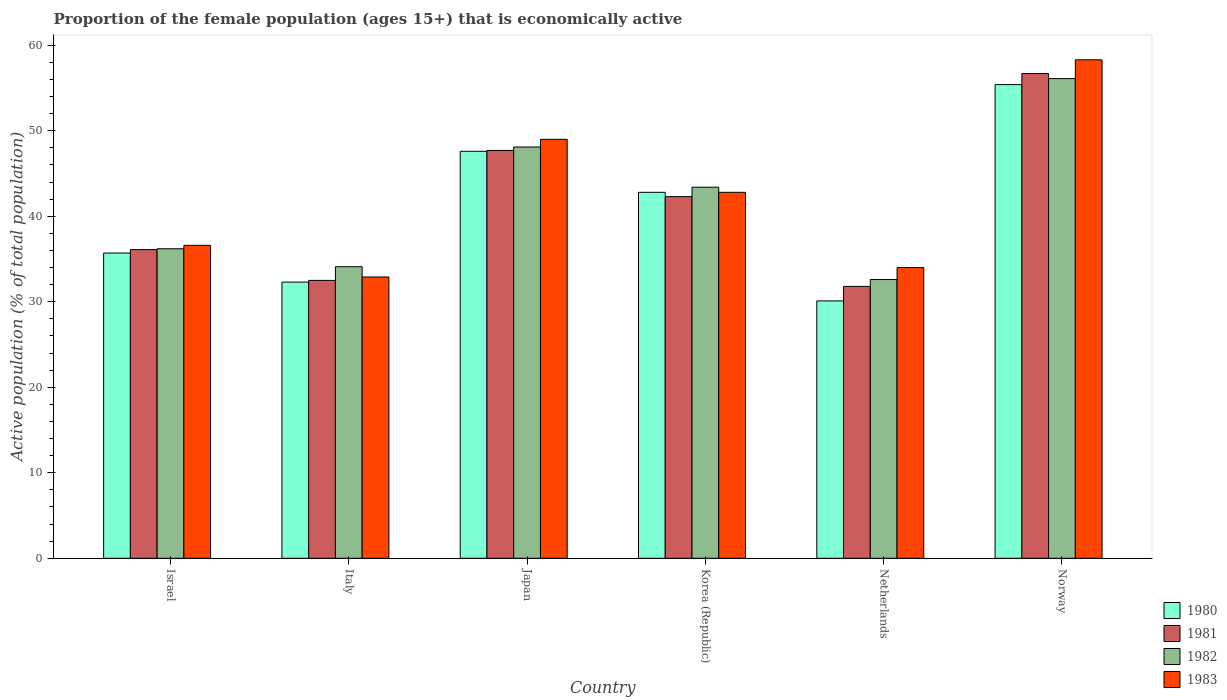How many groups of bars are there?
Offer a very short reply. 6. Are the number of bars per tick equal to the number of legend labels?
Ensure brevity in your answer.  Yes. How many bars are there on the 1st tick from the left?
Give a very brief answer. 4. What is the label of the 1st group of bars from the left?
Provide a short and direct response. Israel. What is the proportion of the female population that is economically active in 1982 in Korea (Republic)?
Your answer should be compact. 43.4. Across all countries, what is the maximum proportion of the female population that is economically active in 1981?
Your answer should be very brief. 56.7. Across all countries, what is the minimum proportion of the female population that is economically active in 1983?
Provide a succinct answer. 32.9. In which country was the proportion of the female population that is economically active in 1983 maximum?
Provide a succinct answer. Norway. In which country was the proportion of the female population that is economically active in 1983 minimum?
Provide a short and direct response. Italy. What is the total proportion of the female population that is economically active in 1980 in the graph?
Keep it short and to the point. 243.9. What is the difference between the proportion of the female population that is economically active in 1982 in Netherlands and that in Norway?
Ensure brevity in your answer.  -23.5. What is the difference between the proportion of the female population that is economically active in 1983 in Norway and the proportion of the female population that is economically active in 1982 in Italy?
Offer a very short reply. 24.2. What is the average proportion of the female population that is economically active in 1983 per country?
Offer a terse response. 42.27. What is the difference between the proportion of the female population that is economically active of/in 1980 and proportion of the female population that is economically active of/in 1982 in Netherlands?
Provide a short and direct response. -2.5. What is the ratio of the proportion of the female population that is economically active in 1981 in Korea (Republic) to that in Netherlands?
Your response must be concise. 1.33. Is the proportion of the female population that is economically active in 1981 in Italy less than that in Korea (Republic)?
Make the answer very short. Yes. What is the difference between the highest and the lowest proportion of the female population that is economically active in 1980?
Give a very brief answer. 25.3. Is the sum of the proportion of the female population that is economically active in 1982 in Japan and Korea (Republic) greater than the maximum proportion of the female population that is economically active in 1980 across all countries?
Ensure brevity in your answer.  Yes. Is it the case that in every country, the sum of the proportion of the female population that is economically active in 1980 and proportion of the female population that is economically active in 1983 is greater than the sum of proportion of the female population that is economically active in 1981 and proportion of the female population that is economically active in 1982?
Offer a terse response. No. What does the 1st bar from the right in Japan represents?
Make the answer very short. 1983. Is it the case that in every country, the sum of the proportion of the female population that is economically active in 1980 and proportion of the female population that is economically active in 1981 is greater than the proportion of the female population that is economically active in 1983?
Offer a terse response. Yes. How many countries are there in the graph?
Provide a short and direct response. 6. Does the graph contain any zero values?
Keep it short and to the point. No. How many legend labels are there?
Offer a very short reply. 4. What is the title of the graph?
Give a very brief answer. Proportion of the female population (ages 15+) that is economically active. What is the label or title of the Y-axis?
Make the answer very short. Active population (% of total population). What is the Active population (% of total population) in 1980 in Israel?
Keep it short and to the point. 35.7. What is the Active population (% of total population) in 1981 in Israel?
Offer a terse response. 36.1. What is the Active population (% of total population) of 1982 in Israel?
Keep it short and to the point. 36.2. What is the Active population (% of total population) in 1983 in Israel?
Offer a very short reply. 36.6. What is the Active population (% of total population) in 1980 in Italy?
Your response must be concise. 32.3. What is the Active population (% of total population) of 1981 in Italy?
Your answer should be very brief. 32.5. What is the Active population (% of total population) of 1982 in Italy?
Offer a terse response. 34.1. What is the Active population (% of total population) of 1983 in Italy?
Make the answer very short. 32.9. What is the Active population (% of total population) of 1980 in Japan?
Your answer should be very brief. 47.6. What is the Active population (% of total population) in 1981 in Japan?
Keep it short and to the point. 47.7. What is the Active population (% of total population) in 1982 in Japan?
Offer a terse response. 48.1. What is the Active population (% of total population) in 1980 in Korea (Republic)?
Offer a terse response. 42.8. What is the Active population (% of total population) of 1981 in Korea (Republic)?
Provide a short and direct response. 42.3. What is the Active population (% of total population) in 1982 in Korea (Republic)?
Make the answer very short. 43.4. What is the Active population (% of total population) in 1983 in Korea (Republic)?
Provide a succinct answer. 42.8. What is the Active population (% of total population) of 1980 in Netherlands?
Keep it short and to the point. 30.1. What is the Active population (% of total population) of 1981 in Netherlands?
Keep it short and to the point. 31.8. What is the Active population (% of total population) in 1982 in Netherlands?
Your answer should be compact. 32.6. What is the Active population (% of total population) in 1980 in Norway?
Your answer should be compact. 55.4. What is the Active population (% of total population) in 1981 in Norway?
Your response must be concise. 56.7. What is the Active population (% of total population) of 1982 in Norway?
Offer a terse response. 56.1. What is the Active population (% of total population) of 1983 in Norway?
Give a very brief answer. 58.3. Across all countries, what is the maximum Active population (% of total population) in 1980?
Offer a terse response. 55.4. Across all countries, what is the maximum Active population (% of total population) in 1981?
Give a very brief answer. 56.7. Across all countries, what is the maximum Active population (% of total population) in 1982?
Offer a terse response. 56.1. Across all countries, what is the maximum Active population (% of total population) in 1983?
Provide a succinct answer. 58.3. Across all countries, what is the minimum Active population (% of total population) of 1980?
Make the answer very short. 30.1. Across all countries, what is the minimum Active population (% of total population) in 1981?
Your answer should be very brief. 31.8. Across all countries, what is the minimum Active population (% of total population) of 1982?
Make the answer very short. 32.6. Across all countries, what is the minimum Active population (% of total population) of 1983?
Your response must be concise. 32.9. What is the total Active population (% of total population) in 1980 in the graph?
Offer a terse response. 243.9. What is the total Active population (% of total population) in 1981 in the graph?
Keep it short and to the point. 247.1. What is the total Active population (% of total population) of 1982 in the graph?
Offer a very short reply. 250.5. What is the total Active population (% of total population) in 1983 in the graph?
Your answer should be compact. 253.6. What is the difference between the Active population (% of total population) of 1981 in Israel and that in Italy?
Provide a short and direct response. 3.6. What is the difference between the Active population (% of total population) in 1983 in Israel and that in Japan?
Offer a terse response. -12.4. What is the difference between the Active population (% of total population) in 1980 in Israel and that in Korea (Republic)?
Provide a short and direct response. -7.1. What is the difference between the Active population (% of total population) of 1981 in Israel and that in Korea (Republic)?
Your response must be concise. -6.2. What is the difference between the Active population (% of total population) of 1982 in Israel and that in Korea (Republic)?
Make the answer very short. -7.2. What is the difference between the Active population (% of total population) in 1982 in Israel and that in Netherlands?
Provide a succinct answer. 3.6. What is the difference between the Active population (% of total population) of 1980 in Israel and that in Norway?
Offer a very short reply. -19.7. What is the difference between the Active population (% of total population) in 1981 in Israel and that in Norway?
Keep it short and to the point. -20.6. What is the difference between the Active population (% of total population) of 1982 in Israel and that in Norway?
Your answer should be very brief. -19.9. What is the difference between the Active population (% of total population) of 1983 in Israel and that in Norway?
Ensure brevity in your answer.  -21.7. What is the difference between the Active population (% of total population) in 1980 in Italy and that in Japan?
Give a very brief answer. -15.3. What is the difference between the Active population (% of total population) in 1981 in Italy and that in Japan?
Ensure brevity in your answer.  -15.2. What is the difference between the Active population (% of total population) of 1982 in Italy and that in Japan?
Give a very brief answer. -14. What is the difference between the Active population (% of total population) of 1983 in Italy and that in Japan?
Provide a succinct answer. -16.1. What is the difference between the Active population (% of total population) in 1983 in Italy and that in Korea (Republic)?
Provide a succinct answer. -9.9. What is the difference between the Active population (% of total population) of 1983 in Italy and that in Netherlands?
Your answer should be compact. -1.1. What is the difference between the Active population (% of total population) of 1980 in Italy and that in Norway?
Offer a terse response. -23.1. What is the difference between the Active population (% of total population) in 1981 in Italy and that in Norway?
Provide a succinct answer. -24.2. What is the difference between the Active population (% of total population) of 1983 in Italy and that in Norway?
Your response must be concise. -25.4. What is the difference between the Active population (% of total population) in 1980 in Japan and that in Korea (Republic)?
Your answer should be very brief. 4.8. What is the difference between the Active population (% of total population) in 1983 in Japan and that in Korea (Republic)?
Offer a very short reply. 6.2. What is the difference between the Active population (% of total population) of 1980 in Japan and that in Netherlands?
Offer a terse response. 17.5. What is the difference between the Active population (% of total population) in 1982 in Japan and that in Netherlands?
Your answer should be compact. 15.5. What is the difference between the Active population (% of total population) in 1983 in Japan and that in Netherlands?
Your response must be concise. 15. What is the difference between the Active population (% of total population) in 1980 in Japan and that in Norway?
Offer a terse response. -7.8. What is the difference between the Active population (% of total population) of 1980 in Korea (Republic) and that in Netherlands?
Offer a very short reply. 12.7. What is the difference between the Active population (% of total population) of 1981 in Korea (Republic) and that in Netherlands?
Ensure brevity in your answer.  10.5. What is the difference between the Active population (% of total population) of 1982 in Korea (Republic) and that in Netherlands?
Provide a succinct answer. 10.8. What is the difference between the Active population (% of total population) of 1983 in Korea (Republic) and that in Netherlands?
Provide a short and direct response. 8.8. What is the difference between the Active population (% of total population) of 1981 in Korea (Republic) and that in Norway?
Offer a very short reply. -14.4. What is the difference between the Active population (% of total population) of 1983 in Korea (Republic) and that in Norway?
Offer a terse response. -15.5. What is the difference between the Active population (% of total population) of 1980 in Netherlands and that in Norway?
Provide a short and direct response. -25.3. What is the difference between the Active population (% of total population) in 1981 in Netherlands and that in Norway?
Your answer should be compact. -24.9. What is the difference between the Active population (% of total population) in 1982 in Netherlands and that in Norway?
Your answer should be compact. -23.5. What is the difference between the Active population (% of total population) in 1983 in Netherlands and that in Norway?
Ensure brevity in your answer.  -24.3. What is the difference between the Active population (% of total population) of 1980 in Israel and the Active population (% of total population) of 1982 in Italy?
Provide a short and direct response. 1.6. What is the difference between the Active population (% of total population) of 1981 in Israel and the Active population (% of total population) of 1982 in Italy?
Offer a terse response. 2. What is the difference between the Active population (% of total population) of 1981 in Israel and the Active population (% of total population) of 1983 in Italy?
Give a very brief answer. 3.2. What is the difference between the Active population (% of total population) of 1980 in Israel and the Active population (% of total population) of 1981 in Japan?
Ensure brevity in your answer.  -12. What is the difference between the Active population (% of total population) in 1980 in Israel and the Active population (% of total population) in 1982 in Japan?
Your answer should be very brief. -12.4. What is the difference between the Active population (% of total population) in 1981 in Israel and the Active population (% of total population) in 1983 in Japan?
Your answer should be very brief. -12.9. What is the difference between the Active population (% of total population) in 1982 in Israel and the Active population (% of total population) in 1983 in Japan?
Keep it short and to the point. -12.8. What is the difference between the Active population (% of total population) of 1981 in Israel and the Active population (% of total population) of 1982 in Korea (Republic)?
Make the answer very short. -7.3. What is the difference between the Active population (% of total population) of 1980 in Israel and the Active population (% of total population) of 1981 in Netherlands?
Your answer should be very brief. 3.9. What is the difference between the Active population (% of total population) of 1980 in Israel and the Active population (% of total population) of 1981 in Norway?
Ensure brevity in your answer.  -21. What is the difference between the Active population (% of total population) in 1980 in Israel and the Active population (% of total population) in 1982 in Norway?
Keep it short and to the point. -20.4. What is the difference between the Active population (% of total population) in 1980 in Israel and the Active population (% of total population) in 1983 in Norway?
Make the answer very short. -22.6. What is the difference between the Active population (% of total population) of 1981 in Israel and the Active population (% of total population) of 1983 in Norway?
Offer a terse response. -22.2. What is the difference between the Active population (% of total population) in 1982 in Israel and the Active population (% of total population) in 1983 in Norway?
Provide a succinct answer. -22.1. What is the difference between the Active population (% of total population) of 1980 in Italy and the Active population (% of total population) of 1981 in Japan?
Your answer should be very brief. -15.4. What is the difference between the Active population (% of total population) in 1980 in Italy and the Active population (% of total population) in 1982 in Japan?
Your answer should be very brief. -15.8. What is the difference between the Active population (% of total population) of 1980 in Italy and the Active population (% of total population) of 1983 in Japan?
Your answer should be compact. -16.7. What is the difference between the Active population (% of total population) in 1981 in Italy and the Active population (% of total population) in 1982 in Japan?
Ensure brevity in your answer.  -15.6. What is the difference between the Active population (% of total population) of 1981 in Italy and the Active population (% of total population) of 1983 in Japan?
Your answer should be very brief. -16.5. What is the difference between the Active population (% of total population) in 1982 in Italy and the Active population (% of total population) in 1983 in Japan?
Keep it short and to the point. -14.9. What is the difference between the Active population (% of total population) of 1980 in Italy and the Active population (% of total population) of 1982 in Korea (Republic)?
Your answer should be compact. -11.1. What is the difference between the Active population (% of total population) in 1981 in Italy and the Active population (% of total population) in 1982 in Korea (Republic)?
Give a very brief answer. -10.9. What is the difference between the Active population (% of total population) in 1982 in Italy and the Active population (% of total population) in 1983 in Korea (Republic)?
Keep it short and to the point. -8.7. What is the difference between the Active population (% of total population) of 1980 in Italy and the Active population (% of total population) of 1981 in Netherlands?
Offer a very short reply. 0.5. What is the difference between the Active population (% of total population) of 1982 in Italy and the Active population (% of total population) of 1983 in Netherlands?
Ensure brevity in your answer.  0.1. What is the difference between the Active population (% of total population) in 1980 in Italy and the Active population (% of total population) in 1981 in Norway?
Your response must be concise. -24.4. What is the difference between the Active population (% of total population) in 1980 in Italy and the Active population (% of total population) in 1982 in Norway?
Provide a short and direct response. -23.8. What is the difference between the Active population (% of total population) of 1980 in Italy and the Active population (% of total population) of 1983 in Norway?
Your response must be concise. -26. What is the difference between the Active population (% of total population) of 1981 in Italy and the Active population (% of total population) of 1982 in Norway?
Your answer should be compact. -23.6. What is the difference between the Active population (% of total population) of 1981 in Italy and the Active population (% of total population) of 1983 in Norway?
Your answer should be compact. -25.8. What is the difference between the Active population (% of total population) in 1982 in Italy and the Active population (% of total population) in 1983 in Norway?
Provide a short and direct response. -24.2. What is the difference between the Active population (% of total population) in 1980 in Japan and the Active population (% of total population) in 1982 in Korea (Republic)?
Give a very brief answer. 4.2. What is the difference between the Active population (% of total population) of 1982 in Japan and the Active population (% of total population) of 1983 in Korea (Republic)?
Your answer should be compact. 5.3. What is the difference between the Active population (% of total population) of 1980 in Japan and the Active population (% of total population) of 1983 in Netherlands?
Provide a succinct answer. 13.6. What is the difference between the Active population (% of total population) of 1981 in Japan and the Active population (% of total population) of 1983 in Netherlands?
Offer a very short reply. 13.7. What is the difference between the Active population (% of total population) in 1982 in Japan and the Active population (% of total population) in 1983 in Netherlands?
Provide a succinct answer. 14.1. What is the difference between the Active population (% of total population) in 1980 in Japan and the Active population (% of total population) in 1982 in Norway?
Keep it short and to the point. -8.5. What is the difference between the Active population (% of total population) in 1981 in Japan and the Active population (% of total population) in 1983 in Norway?
Provide a succinct answer. -10.6. What is the difference between the Active population (% of total population) of 1980 in Korea (Republic) and the Active population (% of total population) of 1982 in Netherlands?
Provide a succinct answer. 10.2. What is the difference between the Active population (% of total population) of 1980 in Korea (Republic) and the Active population (% of total population) of 1983 in Netherlands?
Provide a succinct answer. 8.8. What is the difference between the Active population (% of total population) in 1981 in Korea (Republic) and the Active population (% of total population) in 1982 in Netherlands?
Provide a short and direct response. 9.7. What is the difference between the Active population (% of total population) in 1981 in Korea (Republic) and the Active population (% of total population) in 1983 in Netherlands?
Keep it short and to the point. 8.3. What is the difference between the Active population (% of total population) of 1980 in Korea (Republic) and the Active population (% of total population) of 1982 in Norway?
Ensure brevity in your answer.  -13.3. What is the difference between the Active population (% of total population) in 1980 in Korea (Republic) and the Active population (% of total population) in 1983 in Norway?
Offer a very short reply. -15.5. What is the difference between the Active population (% of total population) in 1981 in Korea (Republic) and the Active population (% of total population) in 1982 in Norway?
Provide a succinct answer. -13.8. What is the difference between the Active population (% of total population) of 1981 in Korea (Republic) and the Active population (% of total population) of 1983 in Norway?
Offer a very short reply. -16. What is the difference between the Active population (% of total population) in 1982 in Korea (Republic) and the Active population (% of total population) in 1983 in Norway?
Provide a succinct answer. -14.9. What is the difference between the Active population (% of total population) of 1980 in Netherlands and the Active population (% of total population) of 1981 in Norway?
Give a very brief answer. -26.6. What is the difference between the Active population (% of total population) of 1980 in Netherlands and the Active population (% of total population) of 1983 in Norway?
Provide a succinct answer. -28.2. What is the difference between the Active population (% of total population) in 1981 in Netherlands and the Active population (% of total population) in 1982 in Norway?
Offer a very short reply. -24.3. What is the difference between the Active population (% of total population) of 1981 in Netherlands and the Active population (% of total population) of 1983 in Norway?
Ensure brevity in your answer.  -26.5. What is the difference between the Active population (% of total population) in 1982 in Netherlands and the Active population (% of total population) in 1983 in Norway?
Offer a very short reply. -25.7. What is the average Active population (% of total population) of 1980 per country?
Ensure brevity in your answer.  40.65. What is the average Active population (% of total population) in 1981 per country?
Offer a very short reply. 41.18. What is the average Active population (% of total population) of 1982 per country?
Offer a very short reply. 41.75. What is the average Active population (% of total population) in 1983 per country?
Offer a very short reply. 42.27. What is the difference between the Active population (% of total population) in 1980 and Active population (% of total population) in 1981 in Israel?
Your answer should be compact. -0.4. What is the difference between the Active population (% of total population) in 1981 and Active population (% of total population) in 1983 in Israel?
Your answer should be very brief. -0.5. What is the difference between the Active population (% of total population) of 1982 and Active population (% of total population) of 1983 in Israel?
Your answer should be compact. -0.4. What is the difference between the Active population (% of total population) in 1980 and Active population (% of total population) in 1982 in Italy?
Make the answer very short. -1.8. What is the difference between the Active population (% of total population) in 1980 and Active population (% of total population) in 1982 in Japan?
Give a very brief answer. -0.5. What is the difference between the Active population (% of total population) of 1981 and Active population (% of total population) of 1982 in Japan?
Your answer should be very brief. -0.4. What is the difference between the Active population (% of total population) of 1982 and Active population (% of total population) of 1983 in Japan?
Provide a short and direct response. -0.9. What is the difference between the Active population (% of total population) of 1980 and Active population (% of total population) of 1981 in Korea (Republic)?
Your response must be concise. 0.5. What is the difference between the Active population (% of total population) in 1980 and Active population (% of total population) in 1982 in Korea (Republic)?
Offer a very short reply. -0.6. What is the difference between the Active population (% of total population) of 1980 and Active population (% of total population) of 1983 in Korea (Republic)?
Your answer should be compact. 0. What is the difference between the Active population (% of total population) of 1980 and Active population (% of total population) of 1981 in Netherlands?
Offer a terse response. -1.7. What is the difference between the Active population (% of total population) in 1981 and Active population (% of total population) in 1983 in Netherlands?
Offer a terse response. -2.2. What is the difference between the Active population (% of total population) in 1980 and Active population (% of total population) in 1981 in Norway?
Keep it short and to the point. -1.3. What is the difference between the Active population (% of total population) of 1981 and Active population (% of total population) of 1983 in Norway?
Ensure brevity in your answer.  -1.6. What is the ratio of the Active population (% of total population) of 1980 in Israel to that in Italy?
Provide a succinct answer. 1.11. What is the ratio of the Active population (% of total population) of 1981 in Israel to that in Italy?
Your response must be concise. 1.11. What is the ratio of the Active population (% of total population) in 1982 in Israel to that in Italy?
Offer a terse response. 1.06. What is the ratio of the Active population (% of total population) in 1983 in Israel to that in Italy?
Give a very brief answer. 1.11. What is the ratio of the Active population (% of total population) in 1980 in Israel to that in Japan?
Offer a very short reply. 0.75. What is the ratio of the Active population (% of total population) in 1981 in Israel to that in Japan?
Give a very brief answer. 0.76. What is the ratio of the Active population (% of total population) in 1982 in Israel to that in Japan?
Provide a short and direct response. 0.75. What is the ratio of the Active population (% of total population) of 1983 in Israel to that in Japan?
Provide a succinct answer. 0.75. What is the ratio of the Active population (% of total population) in 1980 in Israel to that in Korea (Republic)?
Give a very brief answer. 0.83. What is the ratio of the Active population (% of total population) of 1981 in Israel to that in Korea (Republic)?
Offer a very short reply. 0.85. What is the ratio of the Active population (% of total population) in 1982 in Israel to that in Korea (Republic)?
Make the answer very short. 0.83. What is the ratio of the Active population (% of total population) in 1983 in Israel to that in Korea (Republic)?
Offer a very short reply. 0.86. What is the ratio of the Active population (% of total population) of 1980 in Israel to that in Netherlands?
Offer a terse response. 1.19. What is the ratio of the Active population (% of total population) in 1981 in Israel to that in Netherlands?
Provide a succinct answer. 1.14. What is the ratio of the Active population (% of total population) in 1982 in Israel to that in Netherlands?
Your answer should be compact. 1.11. What is the ratio of the Active population (% of total population) in 1983 in Israel to that in Netherlands?
Provide a succinct answer. 1.08. What is the ratio of the Active population (% of total population) of 1980 in Israel to that in Norway?
Ensure brevity in your answer.  0.64. What is the ratio of the Active population (% of total population) of 1981 in Israel to that in Norway?
Provide a succinct answer. 0.64. What is the ratio of the Active population (% of total population) of 1982 in Israel to that in Norway?
Provide a succinct answer. 0.65. What is the ratio of the Active population (% of total population) in 1983 in Israel to that in Norway?
Make the answer very short. 0.63. What is the ratio of the Active population (% of total population) of 1980 in Italy to that in Japan?
Make the answer very short. 0.68. What is the ratio of the Active population (% of total population) of 1981 in Italy to that in Japan?
Provide a succinct answer. 0.68. What is the ratio of the Active population (% of total population) in 1982 in Italy to that in Japan?
Offer a terse response. 0.71. What is the ratio of the Active population (% of total population) of 1983 in Italy to that in Japan?
Your answer should be compact. 0.67. What is the ratio of the Active population (% of total population) in 1980 in Italy to that in Korea (Republic)?
Your answer should be very brief. 0.75. What is the ratio of the Active population (% of total population) of 1981 in Italy to that in Korea (Republic)?
Offer a very short reply. 0.77. What is the ratio of the Active population (% of total population) in 1982 in Italy to that in Korea (Republic)?
Provide a short and direct response. 0.79. What is the ratio of the Active population (% of total population) of 1983 in Italy to that in Korea (Republic)?
Make the answer very short. 0.77. What is the ratio of the Active population (% of total population) in 1980 in Italy to that in Netherlands?
Provide a short and direct response. 1.07. What is the ratio of the Active population (% of total population) in 1981 in Italy to that in Netherlands?
Provide a short and direct response. 1.02. What is the ratio of the Active population (% of total population) of 1982 in Italy to that in Netherlands?
Your answer should be compact. 1.05. What is the ratio of the Active population (% of total population) of 1983 in Italy to that in Netherlands?
Provide a succinct answer. 0.97. What is the ratio of the Active population (% of total population) of 1980 in Italy to that in Norway?
Offer a very short reply. 0.58. What is the ratio of the Active population (% of total population) of 1981 in Italy to that in Norway?
Provide a short and direct response. 0.57. What is the ratio of the Active population (% of total population) of 1982 in Italy to that in Norway?
Ensure brevity in your answer.  0.61. What is the ratio of the Active population (% of total population) in 1983 in Italy to that in Norway?
Keep it short and to the point. 0.56. What is the ratio of the Active population (% of total population) in 1980 in Japan to that in Korea (Republic)?
Offer a terse response. 1.11. What is the ratio of the Active population (% of total population) in 1981 in Japan to that in Korea (Republic)?
Offer a very short reply. 1.13. What is the ratio of the Active population (% of total population) in 1982 in Japan to that in Korea (Republic)?
Your response must be concise. 1.11. What is the ratio of the Active population (% of total population) of 1983 in Japan to that in Korea (Republic)?
Offer a terse response. 1.14. What is the ratio of the Active population (% of total population) of 1980 in Japan to that in Netherlands?
Ensure brevity in your answer.  1.58. What is the ratio of the Active population (% of total population) in 1981 in Japan to that in Netherlands?
Keep it short and to the point. 1.5. What is the ratio of the Active population (% of total population) of 1982 in Japan to that in Netherlands?
Keep it short and to the point. 1.48. What is the ratio of the Active population (% of total population) in 1983 in Japan to that in Netherlands?
Make the answer very short. 1.44. What is the ratio of the Active population (% of total population) in 1980 in Japan to that in Norway?
Give a very brief answer. 0.86. What is the ratio of the Active population (% of total population) of 1981 in Japan to that in Norway?
Give a very brief answer. 0.84. What is the ratio of the Active population (% of total population) of 1982 in Japan to that in Norway?
Provide a short and direct response. 0.86. What is the ratio of the Active population (% of total population) of 1983 in Japan to that in Norway?
Keep it short and to the point. 0.84. What is the ratio of the Active population (% of total population) of 1980 in Korea (Republic) to that in Netherlands?
Provide a short and direct response. 1.42. What is the ratio of the Active population (% of total population) in 1981 in Korea (Republic) to that in Netherlands?
Provide a short and direct response. 1.33. What is the ratio of the Active population (% of total population) in 1982 in Korea (Republic) to that in Netherlands?
Offer a terse response. 1.33. What is the ratio of the Active population (% of total population) in 1983 in Korea (Republic) to that in Netherlands?
Make the answer very short. 1.26. What is the ratio of the Active population (% of total population) in 1980 in Korea (Republic) to that in Norway?
Your answer should be compact. 0.77. What is the ratio of the Active population (% of total population) in 1981 in Korea (Republic) to that in Norway?
Your response must be concise. 0.75. What is the ratio of the Active population (% of total population) in 1982 in Korea (Republic) to that in Norway?
Your answer should be compact. 0.77. What is the ratio of the Active population (% of total population) in 1983 in Korea (Republic) to that in Norway?
Provide a short and direct response. 0.73. What is the ratio of the Active population (% of total population) in 1980 in Netherlands to that in Norway?
Offer a terse response. 0.54. What is the ratio of the Active population (% of total population) of 1981 in Netherlands to that in Norway?
Your answer should be compact. 0.56. What is the ratio of the Active population (% of total population) of 1982 in Netherlands to that in Norway?
Give a very brief answer. 0.58. What is the ratio of the Active population (% of total population) of 1983 in Netherlands to that in Norway?
Your answer should be compact. 0.58. What is the difference between the highest and the second highest Active population (% of total population) in 1982?
Ensure brevity in your answer.  8. What is the difference between the highest and the second highest Active population (% of total population) in 1983?
Your answer should be very brief. 9.3. What is the difference between the highest and the lowest Active population (% of total population) in 1980?
Your answer should be very brief. 25.3. What is the difference between the highest and the lowest Active population (% of total population) of 1981?
Offer a very short reply. 24.9. What is the difference between the highest and the lowest Active population (% of total population) of 1982?
Your answer should be compact. 23.5. What is the difference between the highest and the lowest Active population (% of total population) in 1983?
Make the answer very short. 25.4. 